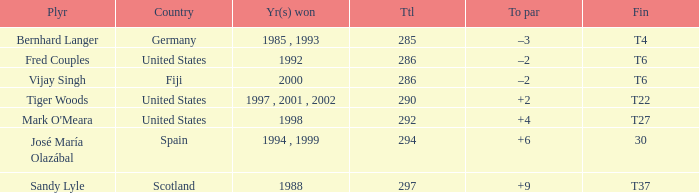Which player has +2 to par? Tiger Woods. 